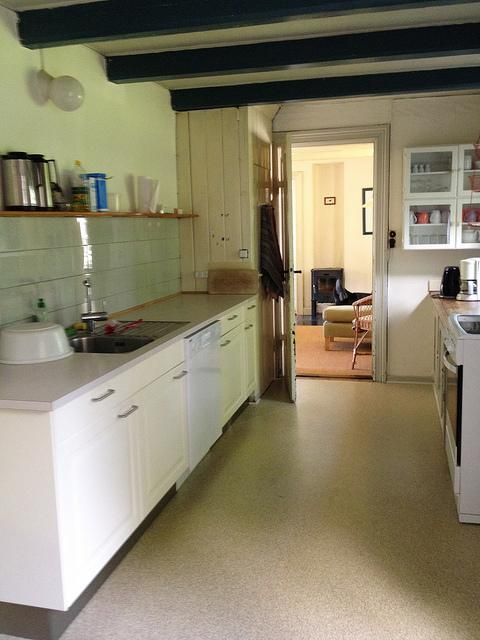What is the most likely activity the person on the yellow chair is doing? watching tv 